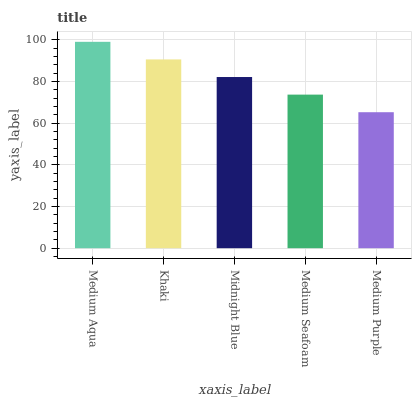Is Khaki the minimum?
Answer yes or no. No. Is Khaki the maximum?
Answer yes or no. No. Is Medium Aqua greater than Khaki?
Answer yes or no. Yes. Is Khaki less than Medium Aqua?
Answer yes or no. Yes. Is Khaki greater than Medium Aqua?
Answer yes or no. No. Is Medium Aqua less than Khaki?
Answer yes or no. No. Is Midnight Blue the high median?
Answer yes or no. Yes. Is Midnight Blue the low median?
Answer yes or no. Yes. Is Medium Aqua the high median?
Answer yes or no. No. Is Medium Purple the low median?
Answer yes or no. No. 